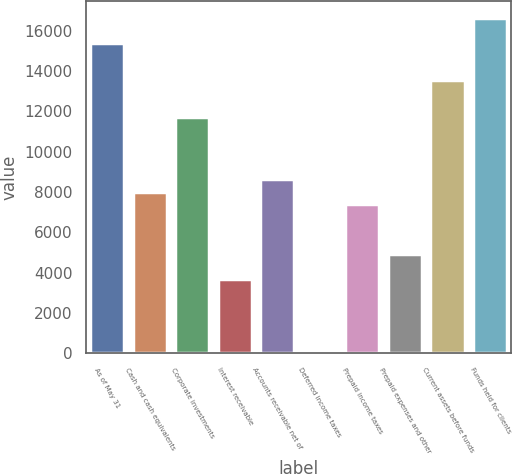<chart> <loc_0><loc_0><loc_500><loc_500><bar_chart><fcel>As of May 31<fcel>Cash and cash equivalents<fcel>Corporate investments<fcel>Interest receivable<fcel>Accounts receivable net of<fcel>Deferred income taxes<fcel>Prepaid income taxes<fcel>Prepaid expenses and other<fcel>Current assets before funds<fcel>Funds held for clients<nl><fcel>15405.8<fcel>8012.12<fcel>11709<fcel>3699.14<fcel>8628.26<fcel>2.3<fcel>7395.98<fcel>4931.42<fcel>13557.4<fcel>16638.1<nl></chart> 